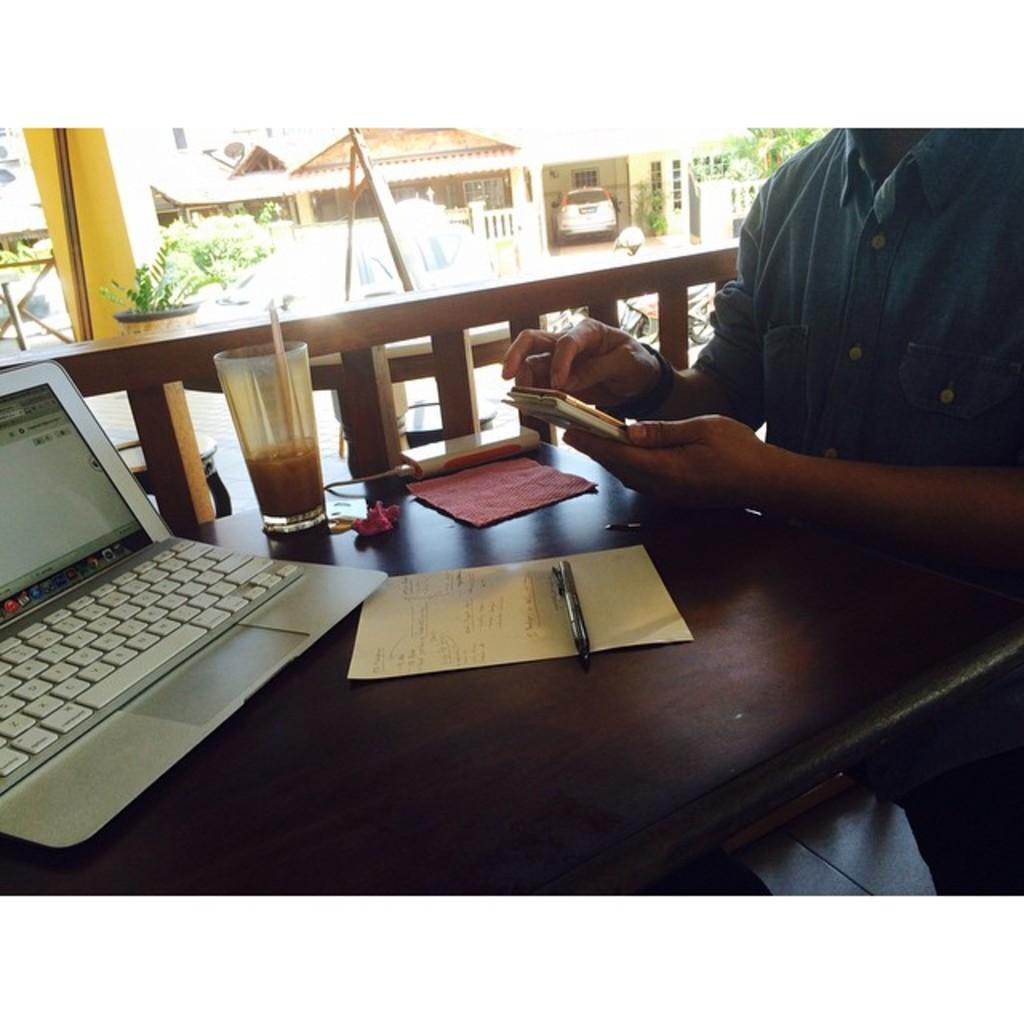What is the main piece of furniture in the image? There is a table in the image. What electronic device is on the table? There is a laptop on the table. What other items are on the table? There is a glass, a paper, and a pen on the table. Who is present in the image? There is a person in the image. What can be seen in the background of the image? There is a house and a car in the background of the image. Is the person in the image wearing a hat? There is no hat visible in the image. Can you tell me how many servants are present in the image? There is no mention of servants in the image, as it only shows a person, a table, and various objects on it. 